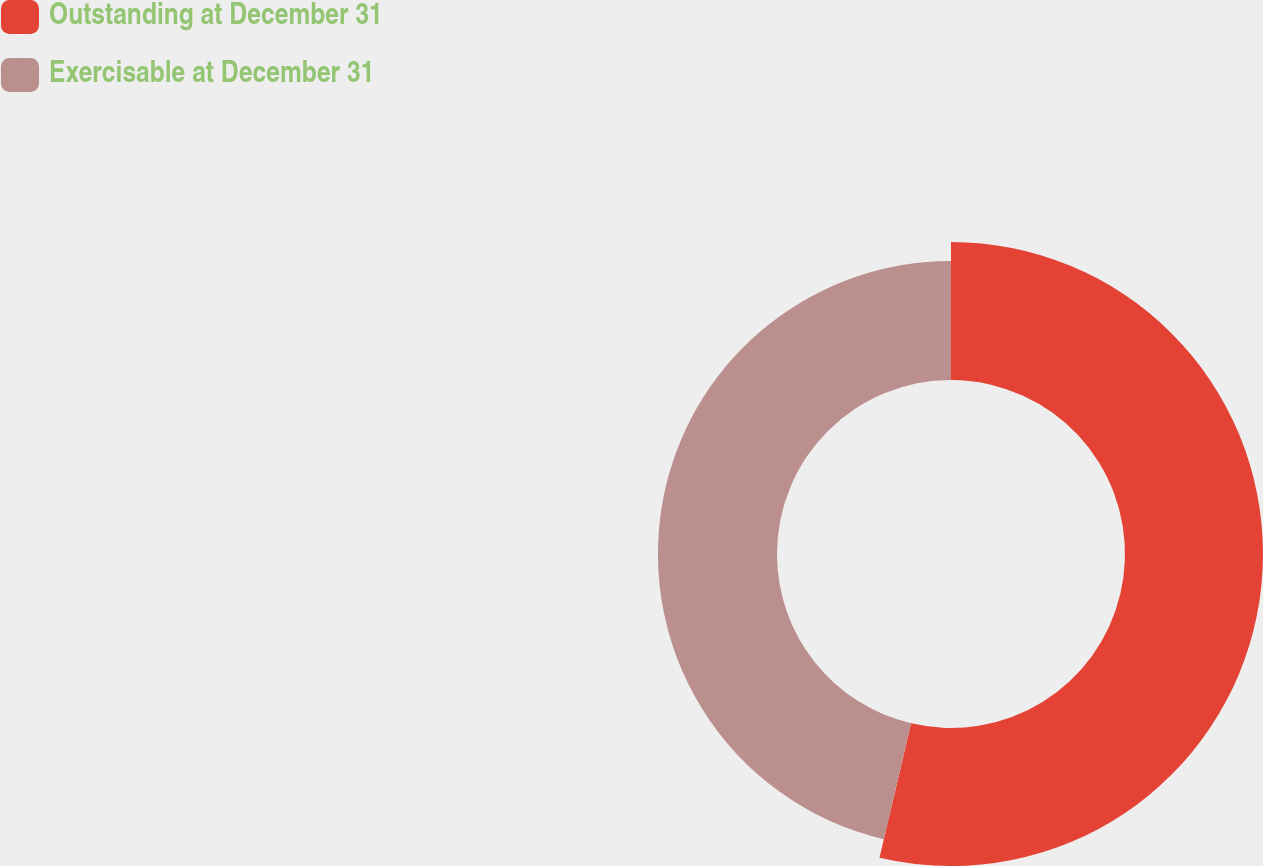Convert chart. <chart><loc_0><loc_0><loc_500><loc_500><pie_chart><fcel>Outstanding at December 31<fcel>Exercisable at December 31<nl><fcel>53.68%<fcel>46.32%<nl></chart> 